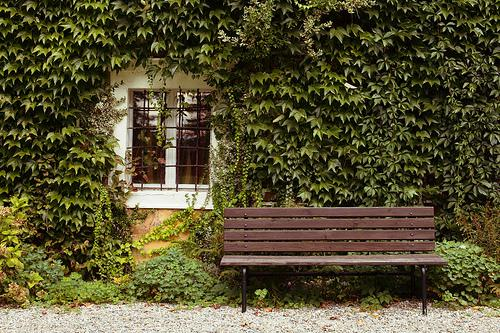Question: how many leaves are on house?
Choices:
A. None.
B. Several.
C. Hundreds.
D. Many thousands.
Answer with the letter. Answer: C Question: what are the leaves from?
Choices:
A. Lemon tree.
B. Rose bush.
C. Orange trees.
D. Vines.
Answer with the letter. Answer: D Question: who is in the window?
Choices:
A. No one.
B. A cat.
C. A man.
D. A woman.
Answer with the letter. Answer: A Question: when will the leaves fall?
Choices:
A. When the tree is dying.
B. In autumn.
C. When its too dry.
D. When fall starts.
Answer with the letter. Answer: B Question: what is bench made from?
Choices:
A. Wood and iron.
B. Metal.
C. Plastic.
D. Concrete.
Answer with the letter. Answer: A Question: where is the bench?
Choices:
A. On ground.
B. On the sidewalk.
C. On the sand.
D. On the grass.
Answer with the letter. Answer: A 